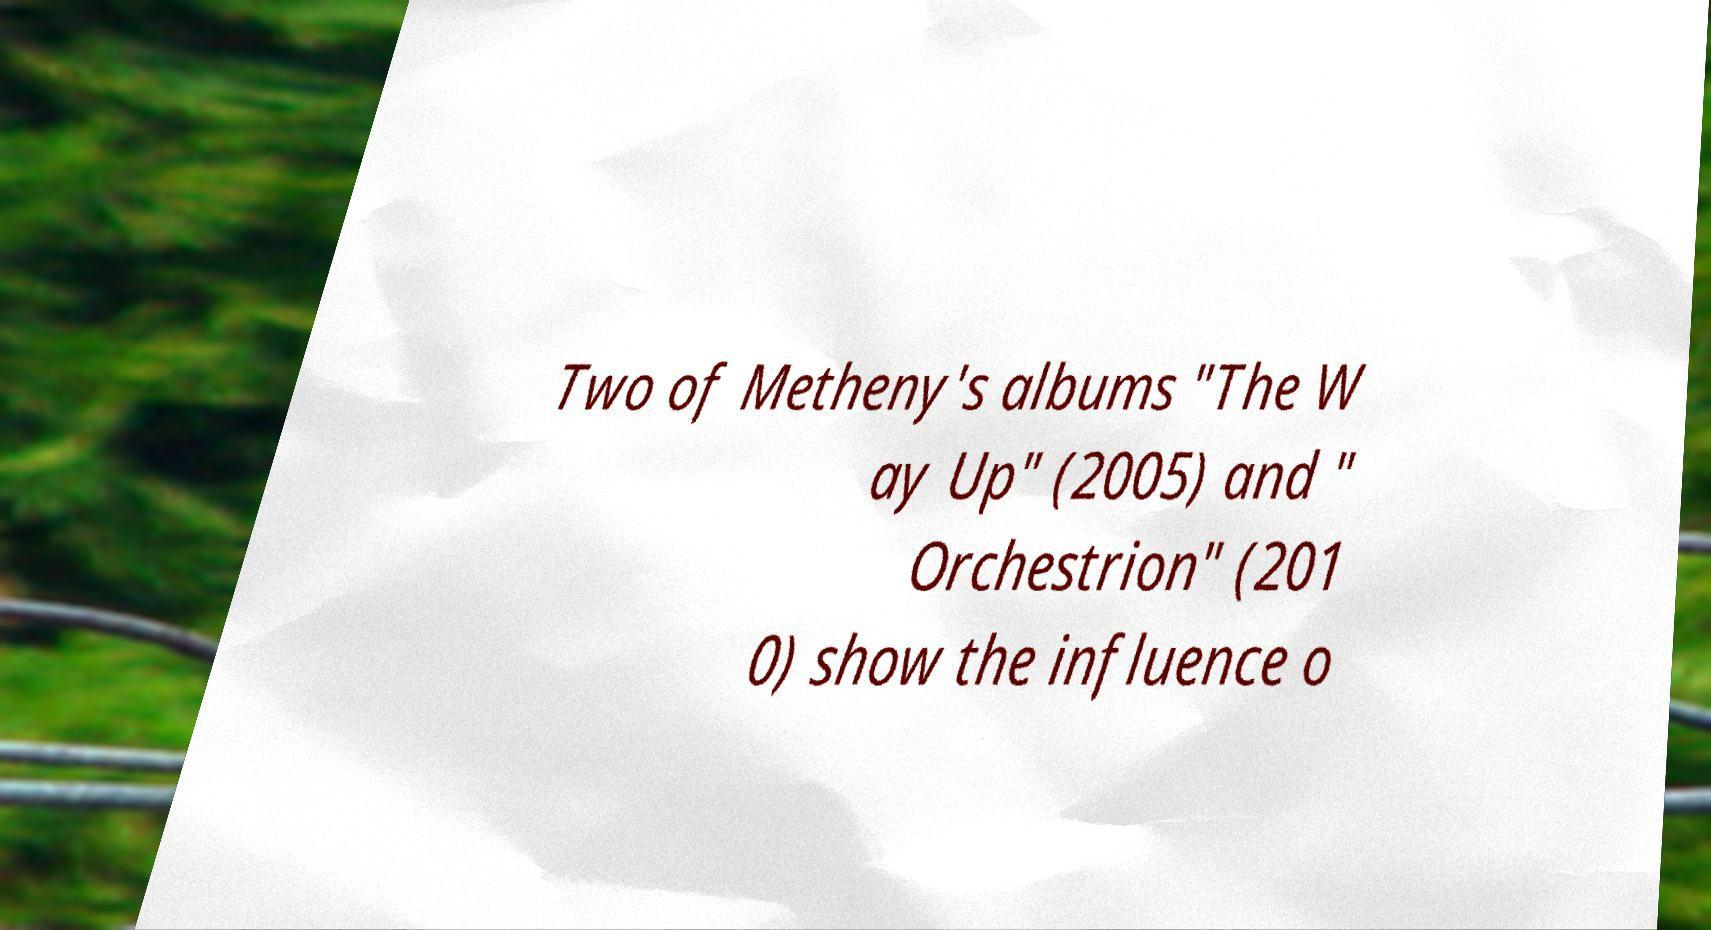Could you extract and type out the text from this image? Two of Metheny's albums "The W ay Up" (2005) and " Orchestrion" (201 0) show the influence o 